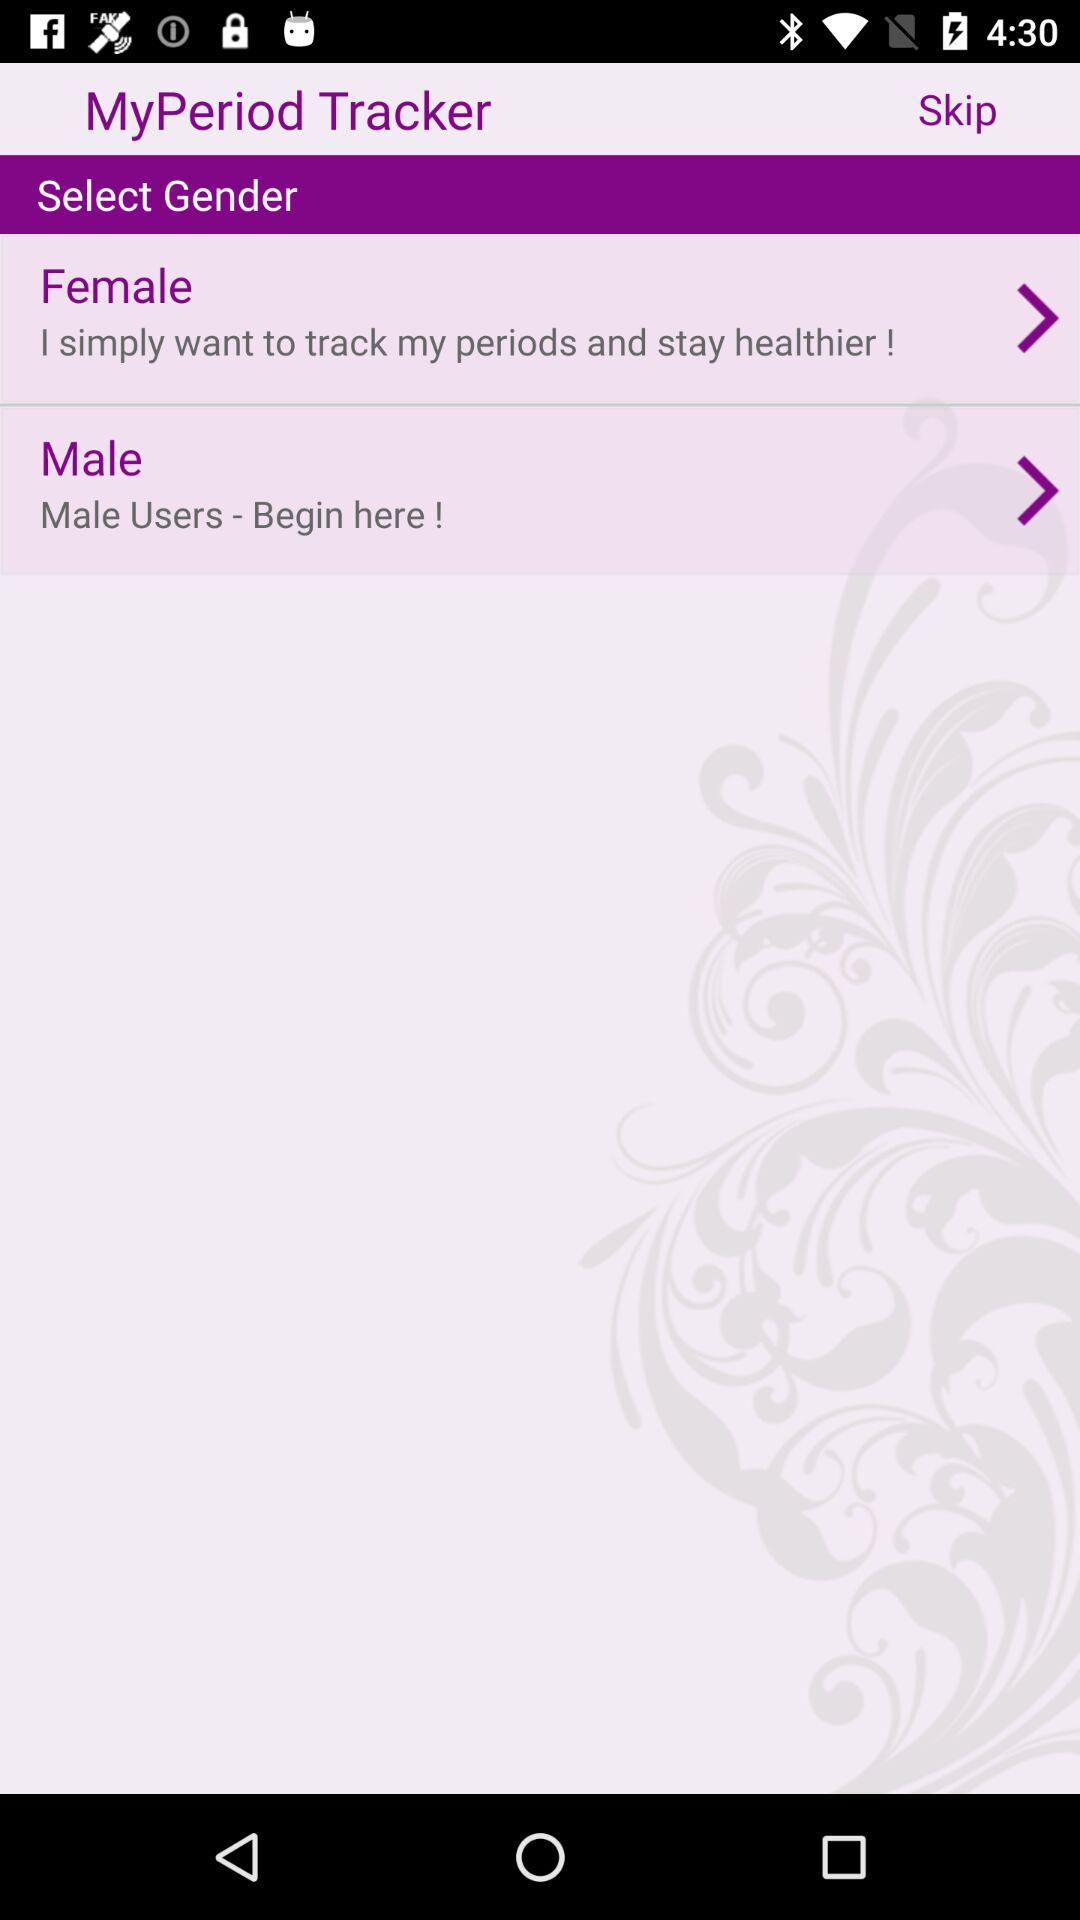What is the application name? The application name is "MyPeriod Tracker". 